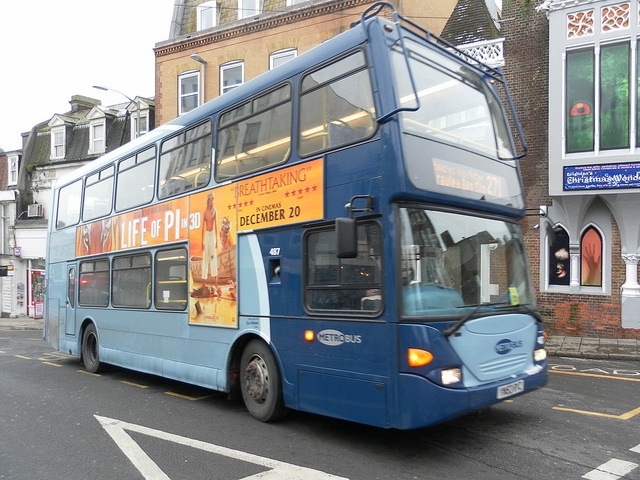Describe the objects in this image and their specific colors. I can see bus in white, gray, darkgray, lightgray, and darkblue tones in this image. 